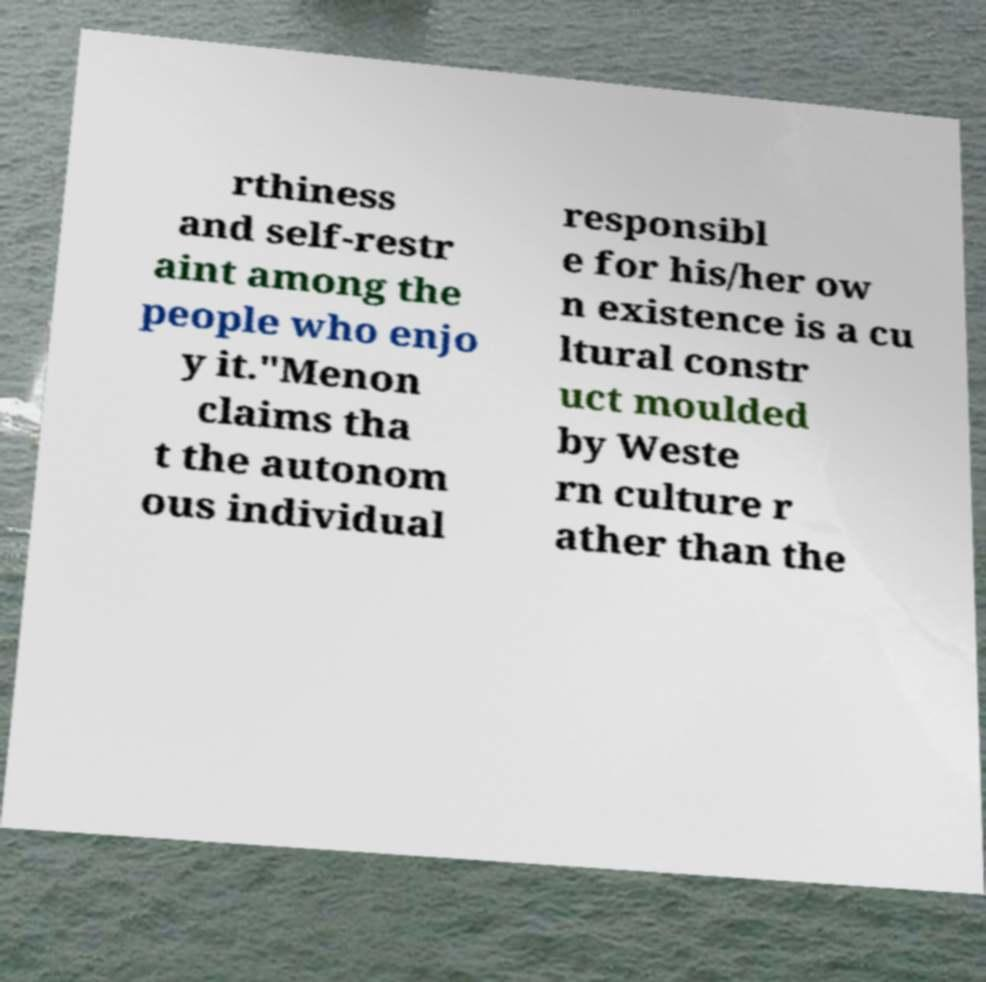Please identify and transcribe the text found in this image. rthiness and self-restr aint among the people who enjo y it."Menon claims tha t the autonom ous individual responsibl e for his/her ow n existence is a cu ltural constr uct moulded by Weste rn culture r ather than the 